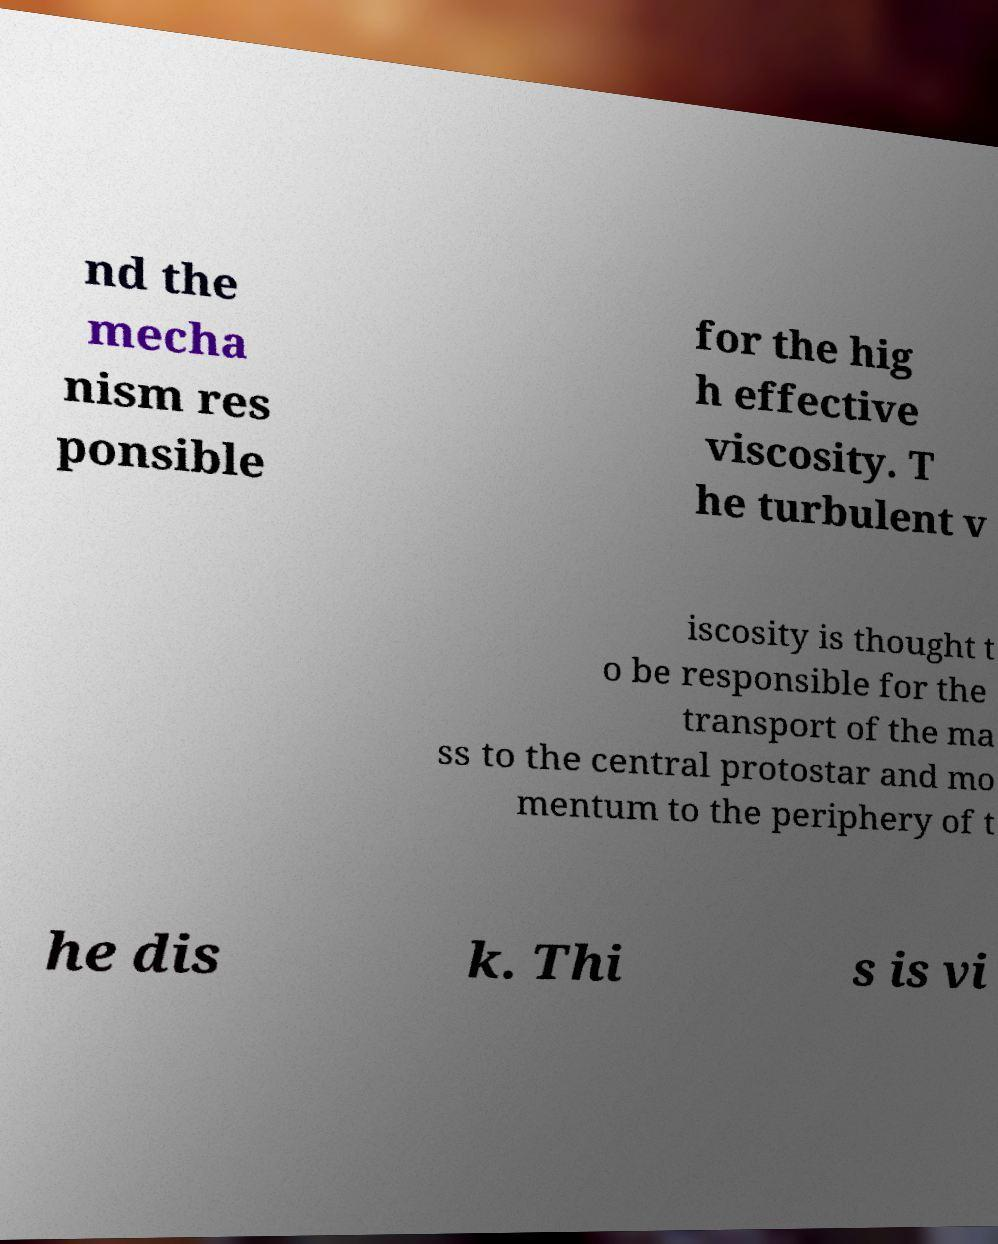There's text embedded in this image that I need extracted. Can you transcribe it verbatim? nd the mecha nism res ponsible for the hig h effective viscosity. T he turbulent v iscosity is thought t o be responsible for the transport of the ma ss to the central protostar and mo mentum to the periphery of t he dis k. Thi s is vi 